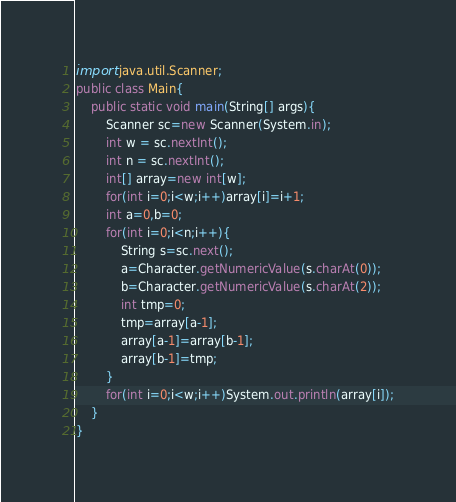Convert code to text. <code><loc_0><loc_0><loc_500><loc_500><_Java_>import java.util.Scanner;
public class Main{
    public static void main(String[] args){
        Scanner sc=new Scanner(System.in);
        int w = sc.nextInt();
        int n = sc.nextInt();
        int[] array=new int[w];
        for(int i=0;i<w;i++)array[i]=i+1;
        int a=0,b=0;
        for(int i=0;i<n;i++){
            String s=sc.next();
            a=Character.getNumericValue(s.charAt(0));
            b=Character.getNumericValue(s.charAt(2));
            int tmp=0;
            tmp=array[a-1];
            array[a-1]=array[b-1];
            array[b-1]=tmp;
        }
        for(int i=0;i<w;i++)System.out.println(array[i]);
    }
}
</code> 